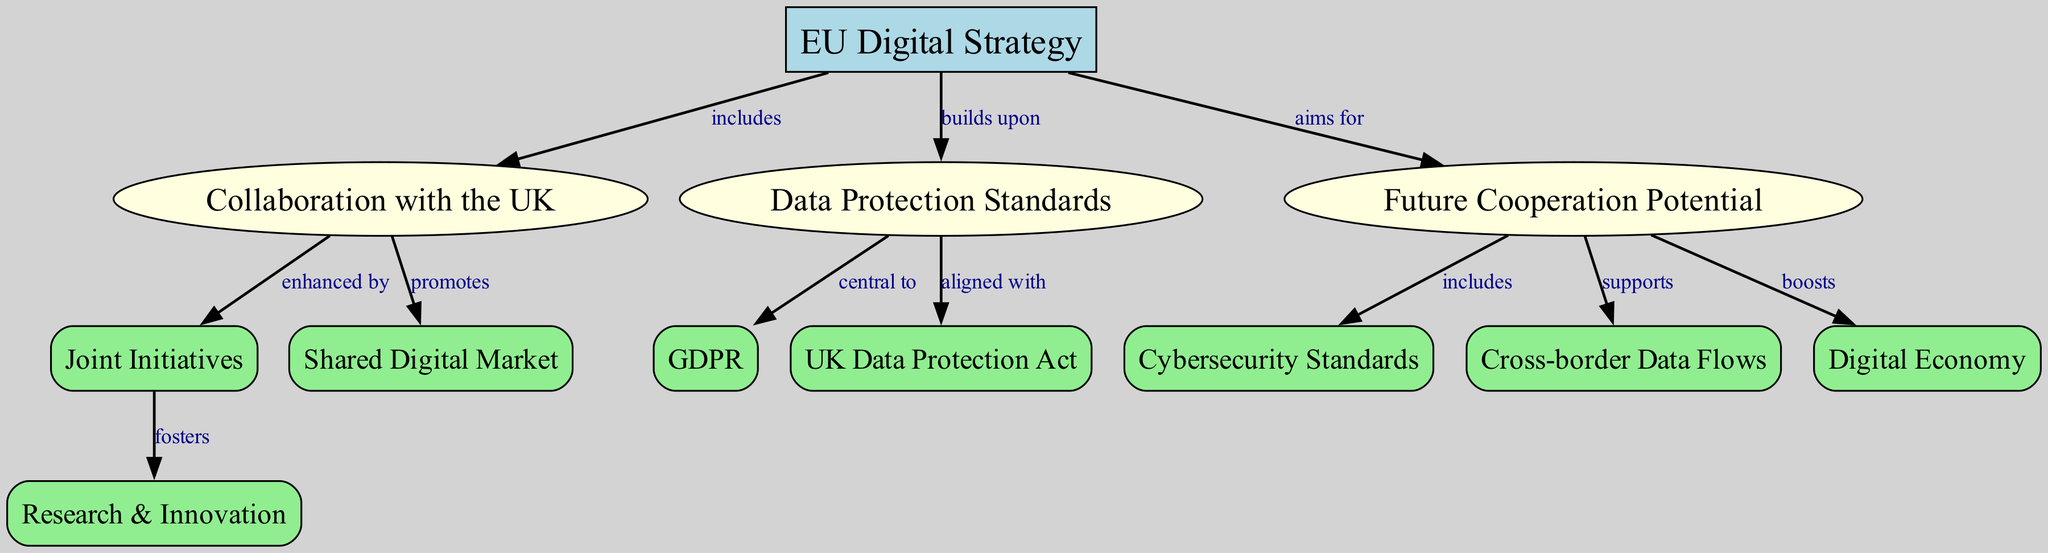What is the central node of the diagram? The central node of the diagram is identified at the top of the hierarchy and is labeled "EU Digital Strategy". This can be confirmed by its unique shape (box) and the fact that it is linked to several other nodes as a primary reference point in the concept map.
Answer: EU Digital Strategy How many nodes are present in the diagram? By counting each item listed under "nodes" in the provided data structure, we identify that there are a total of 12 nodes, which are various categories and concepts related to the EU Digital Strategy.
Answer: 12 Which node is aligned with the UK Data Protection Act? The node that is aligned with the UK Data Protection Act is "Data Protection Standards". This is evident from the directed edge indicating the relationship between these two nodes, showing that it follows from the "aligned with" label.
Answer: Data Protection Standards What relationship does the EU Digital Strategy have with Collaboration with the UK? The relationship is indicated by the edge that shows "EU Digital Strategy" includes "Collaboration with the UK". This shows that the latter is a part of the former, reflecting their interrelated nature within the context of the concept map.
Answer: includes What does Future Cooperation Potential boost according to the diagram? The diagram shows that "Future Cooperation Potential" boosts "Digital Economy". This is linked with an edge labeled "boosts", indicating a supportive role in fostering a dynamic economic environment in the future.
Answer: Digital Economy How does Collaboration with the UK enhance research and innovation? The enhancement of research and innovation is conveyed through the edge linking "Collaboration with the UK" and "Joint Initiatives", which highlights that collaborative efforts contribute positively to innovative research projects and initiatives.
Answer: Joint Initiatives Which two nodes support cross-border data flows in the concept map? The nodes supporting cross-border data flows according to the edges in the diagram are "Future Cooperation Potential" and "Data Protection Standards". The edge from "Future Cooperation Potential" shows it supports cross-border data flows.
Answer: Future Cooperation Potential, Data Protection Standards What is central to Data Protection Standards based on the diagram? "GDPR" is central to Data Protection Standards as indicated by the edge relationship stating "Data Protection Standards is central to GDPR". This signifies its foundational importance in the context of EU data regulations.
Answer: GDPR How many edges are in the diagram? By counting the relationships defined in the edge list of the provided data, we determine there are a total of 11 edges, each representing a distinct connection between various nodes in the concept map.
Answer: 11 